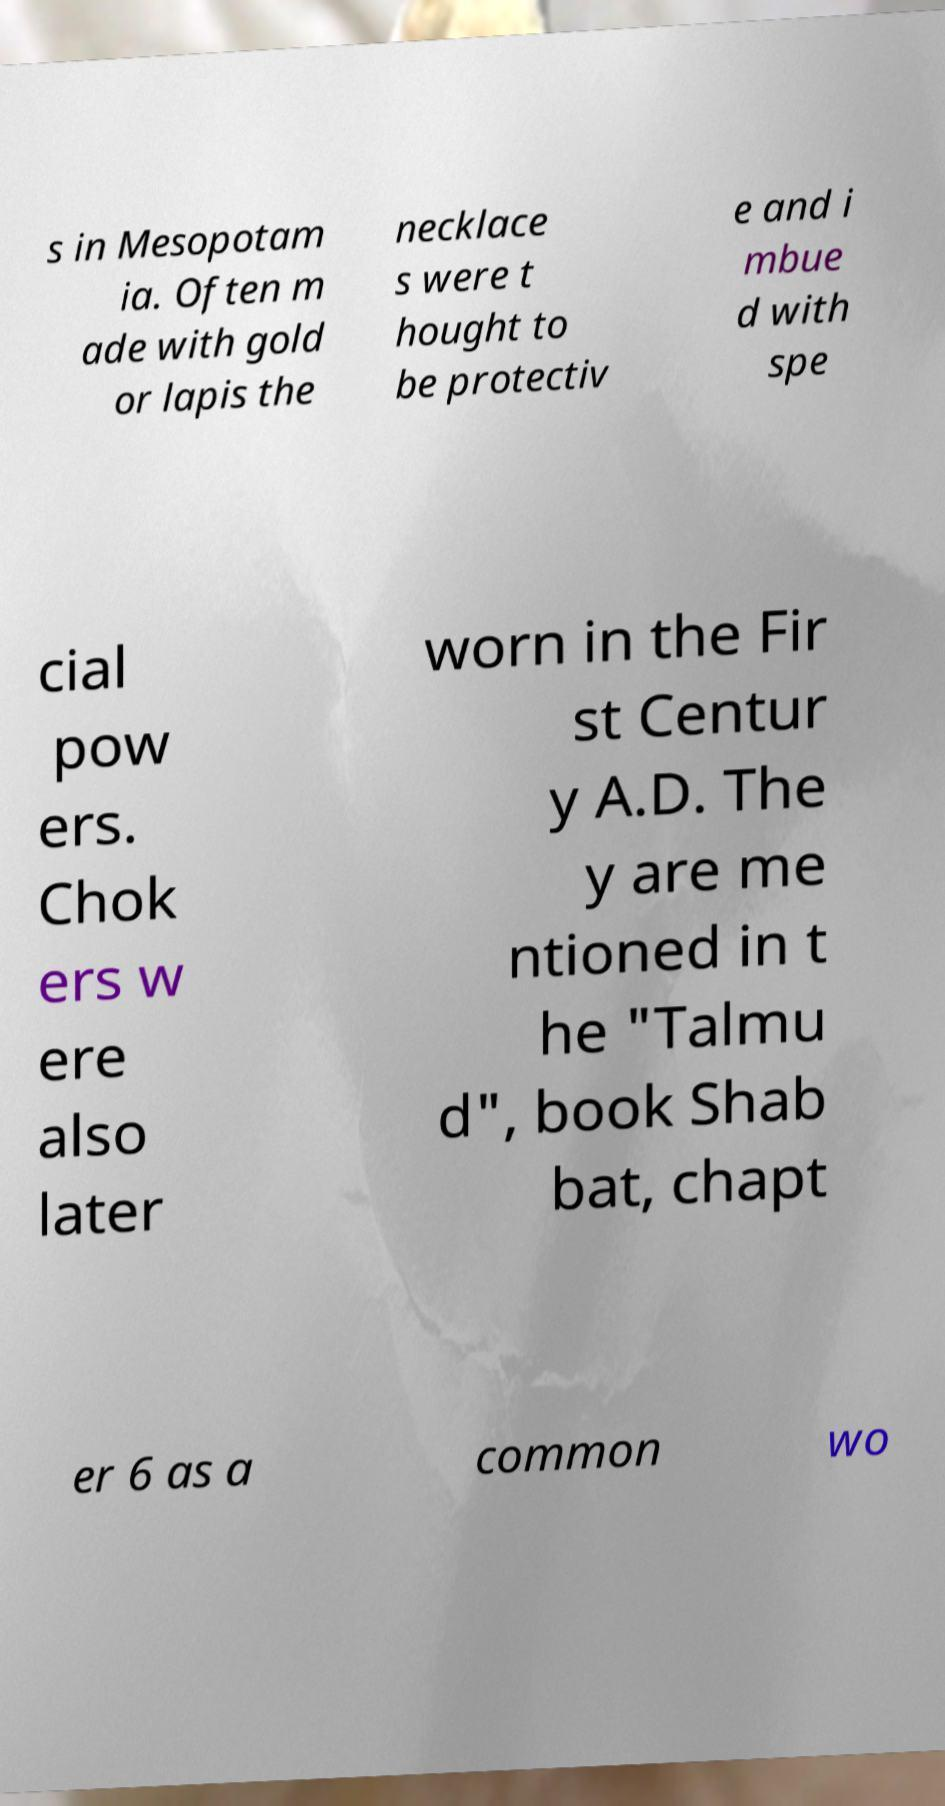Could you assist in decoding the text presented in this image and type it out clearly? s in Mesopotam ia. Often m ade with gold or lapis the necklace s were t hought to be protectiv e and i mbue d with spe cial pow ers. Chok ers w ere also later worn in the Fir st Centur y A.D. The y are me ntioned in t he "Talmu d", book Shab bat, chapt er 6 as a common wo 